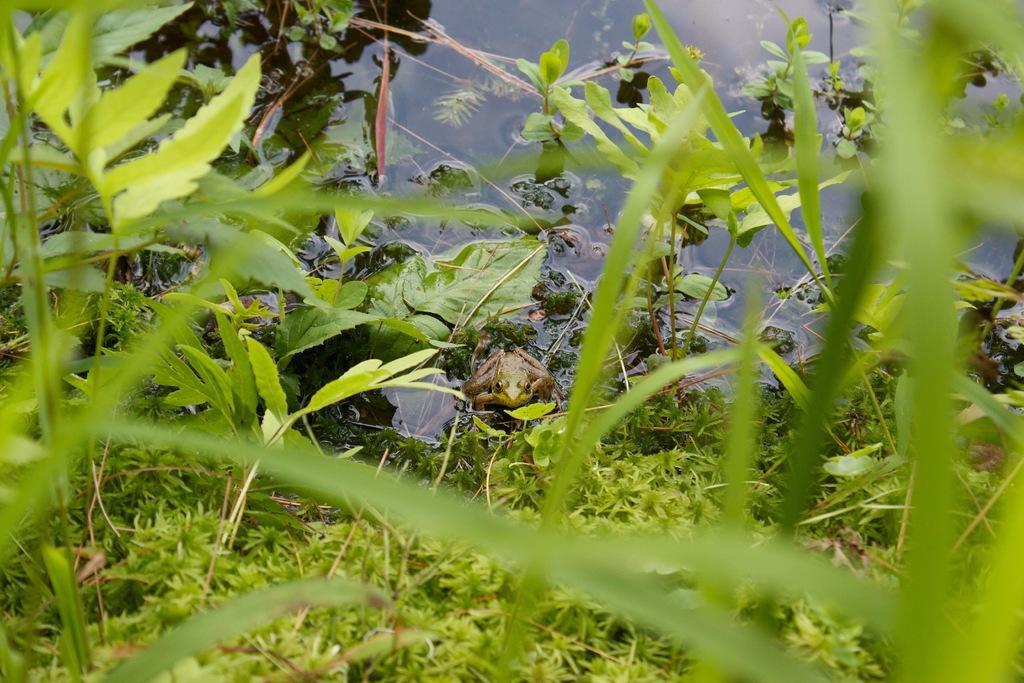In one or two sentences, can you explain what this image depicts? In the center of the image we can see a frog. In the background of the image we can see some plants, water. 